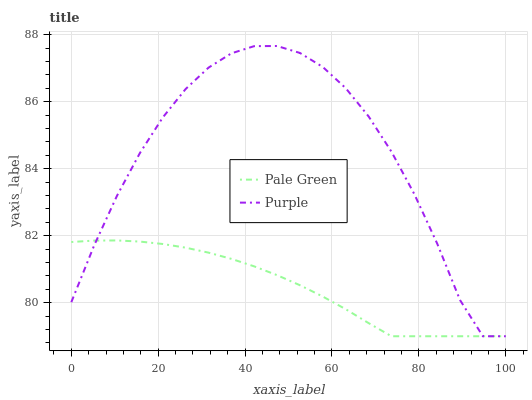Does Pale Green have the minimum area under the curve?
Answer yes or no. Yes. Does Purple have the maximum area under the curve?
Answer yes or no. Yes. Does Pale Green have the maximum area under the curve?
Answer yes or no. No. Is Pale Green the smoothest?
Answer yes or no. Yes. Is Purple the roughest?
Answer yes or no. Yes. Is Pale Green the roughest?
Answer yes or no. No. Does Purple have the lowest value?
Answer yes or no. Yes. Does Purple have the highest value?
Answer yes or no. Yes. Does Pale Green have the highest value?
Answer yes or no. No. Does Purple intersect Pale Green?
Answer yes or no. Yes. Is Purple less than Pale Green?
Answer yes or no. No. Is Purple greater than Pale Green?
Answer yes or no. No. 